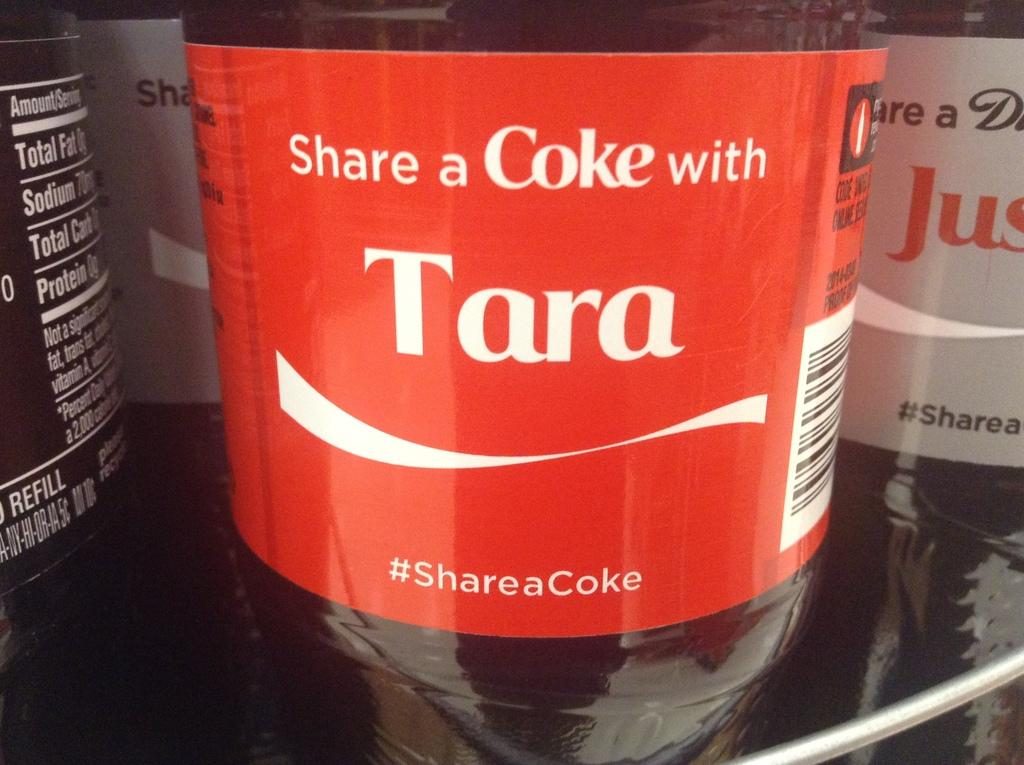<image>
Render a clear and concise summary of the photo. A coke bottle with the name Tara on it. 